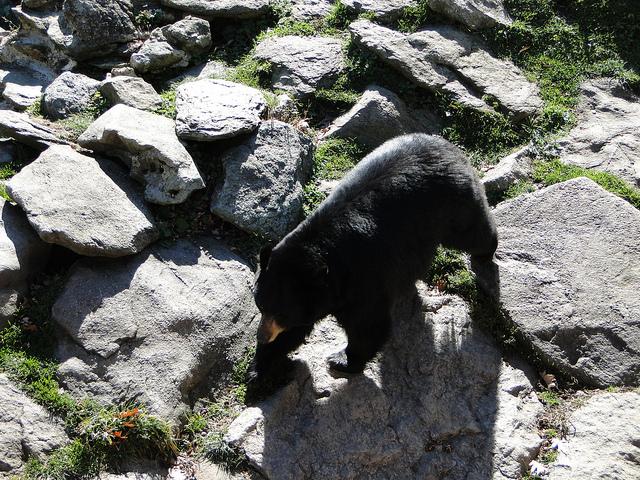Is there any flora visible in this picture besides grass?
Give a very brief answer. Yes. IS this the only animal?
Keep it brief. Yes. Which animal is this?
Answer briefly. Bear. 